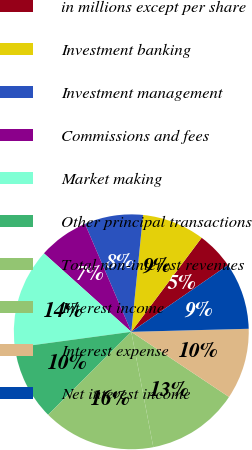Convert chart. <chart><loc_0><loc_0><loc_500><loc_500><pie_chart><fcel>in millions except per share<fcel>Investment banking<fcel>Investment management<fcel>Commissions and fees<fcel>Market making<fcel>Other principal transactions<fcel>Total non-interest revenues<fcel>Interest income<fcel>Interest expense<fcel>Net interest income<nl><fcel>5.17%<fcel>8.62%<fcel>8.05%<fcel>6.9%<fcel>13.79%<fcel>10.34%<fcel>15.52%<fcel>12.64%<fcel>9.77%<fcel>9.2%<nl></chart> 